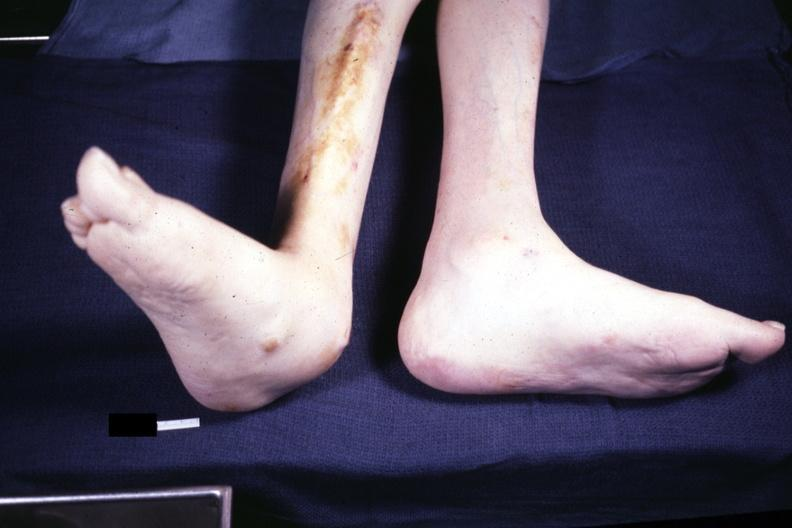what are present?
Answer the question using a single word or phrase. Extremities 